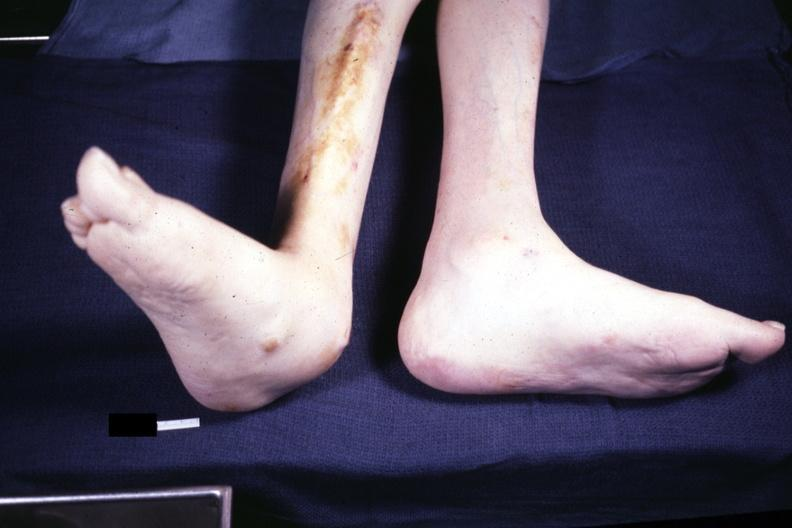what are present?
Answer the question using a single word or phrase. Extremities 